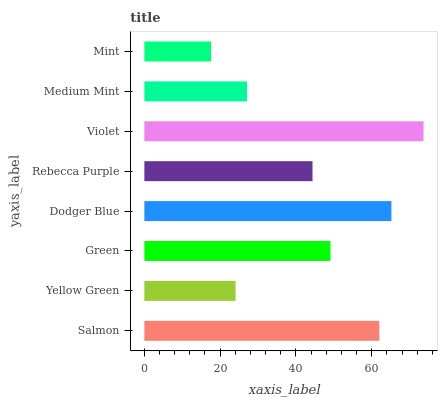Is Mint the minimum?
Answer yes or no. Yes. Is Violet the maximum?
Answer yes or no. Yes. Is Yellow Green the minimum?
Answer yes or no. No. Is Yellow Green the maximum?
Answer yes or no. No. Is Salmon greater than Yellow Green?
Answer yes or no. Yes. Is Yellow Green less than Salmon?
Answer yes or no. Yes. Is Yellow Green greater than Salmon?
Answer yes or no. No. Is Salmon less than Yellow Green?
Answer yes or no. No. Is Green the high median?
Answer yes or no. Yes. Is Rebecca Purple the low median?
Answer yes or no. Yes. Is Yellow Green the high median?
Answer yes or no. No. Is Green the low median?
Answer yes or no. No. 